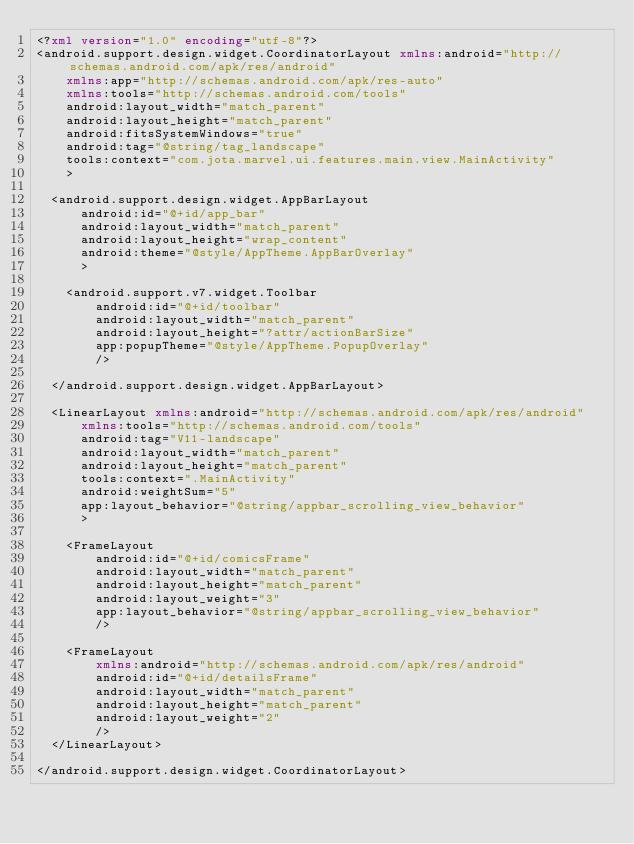Convert code to text. <code><loc_0><loc_0><loc_500><loc_500><_XML_><?xml version="1.0" encoding="utf-8"?>
<android.support.design.widget.CoordinatorLayout xmlns:android="http://schemas.android.com/apk/res/android"
    xmlns:app="http://schemas.android.com/apk/res-auto"
    xmlns:tools="http://schemas.android.com/tools"
    android:layout_width="match_parent"
    android:layout_height="match_parent"
    android:fitsSystemWindows="true"
    android:tag="@string/tag_landscape"
    tools:context="com.jota.marvel.ui.features.main.view.MainActivity"
    >

  <android.support.design.widget.AppBarLayout
      android:id="@+id/app_bar"
      android:layout_width="match_parent"
      android:layout_height="wrap_content"
      android:theme="@style/AppTheme.AppBarOverlay"
      >

    <android.support.v7.widget.Toolbar
        android:id="@+id/toolbar"
        android:layout_width="match_parent"
        android:layout_height="?attr/actionBarSize"
        app:popupTheme="@style/AppTheme.PopupOverlay"
        />

  </android.support.design.widget.AppBarLayout>

  <LinearLayout xmlns:android="http://schemas.android.com/apk/res/android"
      xmlns:tools="http://schemas.android.com/tools"
      android:tag="V11-landscape"
      android:layout_width="match_parent"
      android:layout_height="match_parent"
      tools:context=".MainActivity"
      android:weightSum="5"
      app:layout_behavior="@string/appbar_scrolling_view_behavior"
      >

    <FrameLayout
        android:id="@+id/comicsFrame"
        android:layout_width="match_parent"
        android:layout_height="match_parent"
        android:layout_weight="3"
        app:layout_behavior="@string/appbar_scrolling_view_behavior"
        />

    <FrameLayout
        xmlns:android="http://schemas.android.com/apk/res/android"
        android:id="@+id/detailsFrame"
        android:layout_width="match_parent"
        android:layout_height="match_parent"
        android:layout_weight="2"
        />
  </LinearLayout>

</android.support.design.widget.CoordinatorLayout></code> 